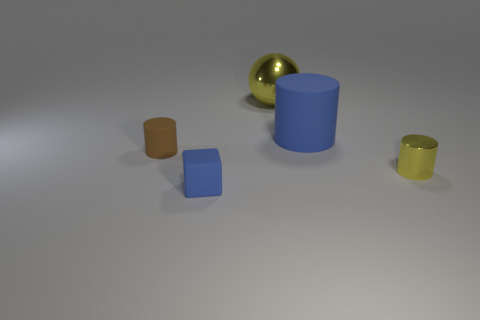Add 5 big cyan blocks. How many objects exist? 10 Subtract all brown cylinders. How many cylinders are left? 2 Subtract all small yellow cylinders. How many cylinders are left? 2 Subtract all cylinders. How many objects are left? 2 Subtract 2 cylinders. How many cylinders are left? 1 Subtract all green cylinders. Subtract all red cubes. How many cylinders are left? 3 Subtract all purple cubes. How many brown cylinders are left? 1 Subtract all blue rubber objects. Subtract all rubber cylinders. How many objects are left? 1 Add 4 yellow metallic cylinders. How many yellow metallic cylinders are left? 5 Add 2 cyan shiny cubes. How many cyan shiny cubes exist? 2 